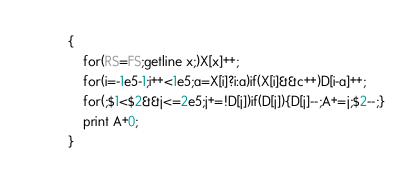Convert code to text. <code><loc_0><loc_0><loc_500><loc_500><_Awk_>{
    for(RS=FS;getline x;)X[x]++;
    for(i=-1e5-1;i++<1e5;a=X[i]?i:a)if(X[i]&&c++)D[i-a]++;
    for(;$1<$2&&j<=2e5;j+=!D[j])if(D[j]){D[j]--;A+=j;$2--;}
    print A+0;
}</code> 